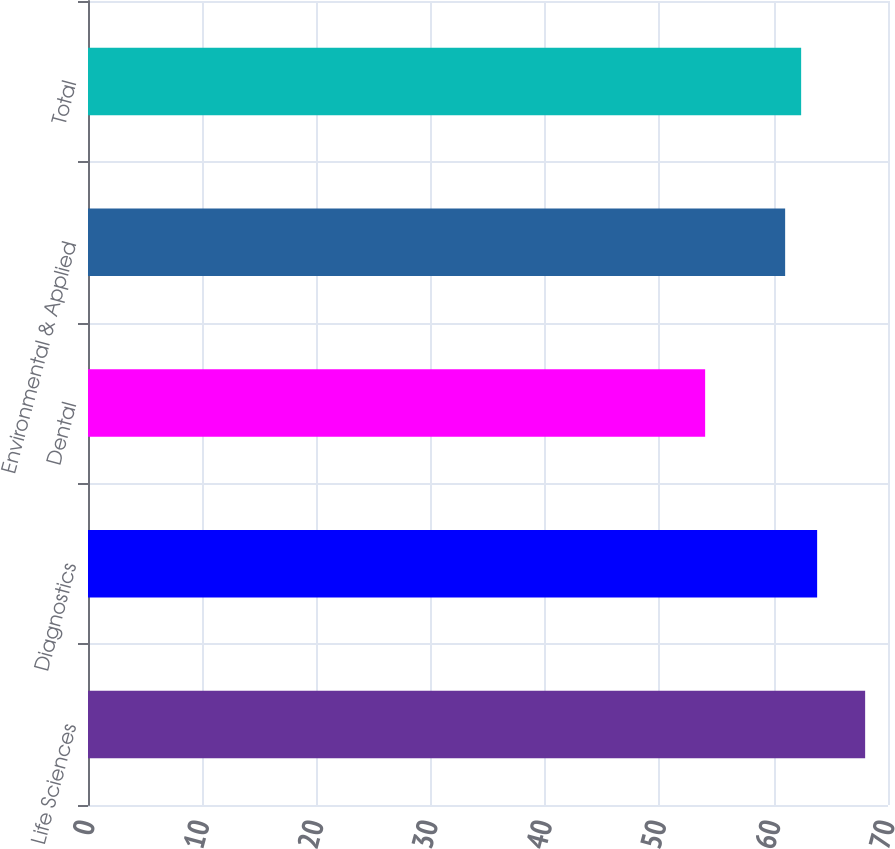Convert chart to OTSL. <chart><loc_0><loc_0><loc_500><loc_500><bar_chart><fcel>Life Sciences<fcel>Diagnostics<fcel>Dental<fcel>Environmental & Applied<fcel>Total<nl><fcel>68<fcel>63.8<fcel>54<fcel>61<fcel>62.4<nl></chart> 